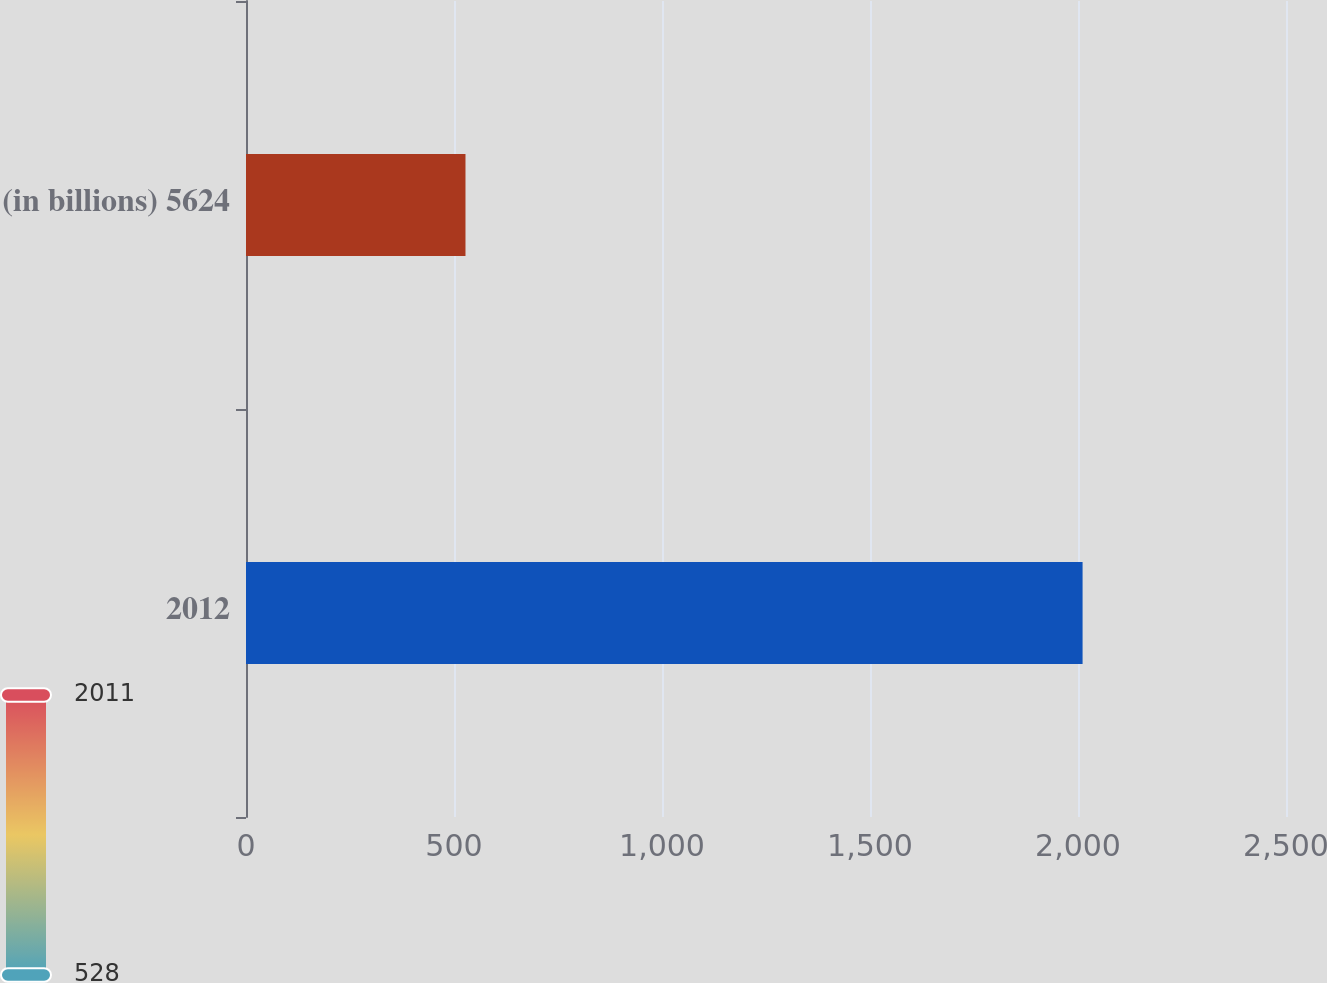<chart> <loc_0><loc_0><loc_500><loc_500><bar_chart><fcel>2012<fcel>(in billions) 5624<nl><fcel>2011<fcel>527.6<nl></chart> 